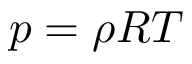<formula> <loc_0><loc_0><loc_500><loc_500>p = \rho R T</formula> 